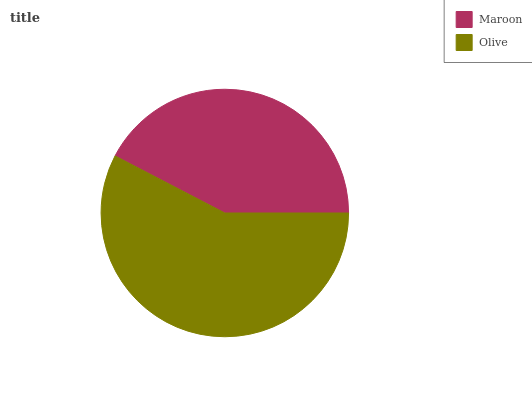Is Maroon the minimum?
Answer yes or no. Yes. Is Olive the maximum?
Answer yes or no. Yes. Is Olive the minimum?
Answer yes or no. No. Is Olive greater than Maroon?
Answer yes or no. Yes. Is Maroon less than Olive?
Answer yes or no. Yes. Is Maroon greater than Olive?
Answer yes or no. No. Is Olive less than Maroon?
Answer yes or no. No. Is Olive the high median?
Answer yes or no. Yes. Is Maroon the low median?
Answer yes or no. Yes. Is Maroon the high median?
Answer yes or no. No. Is Olive the low median?
Answer yes or no. No. 